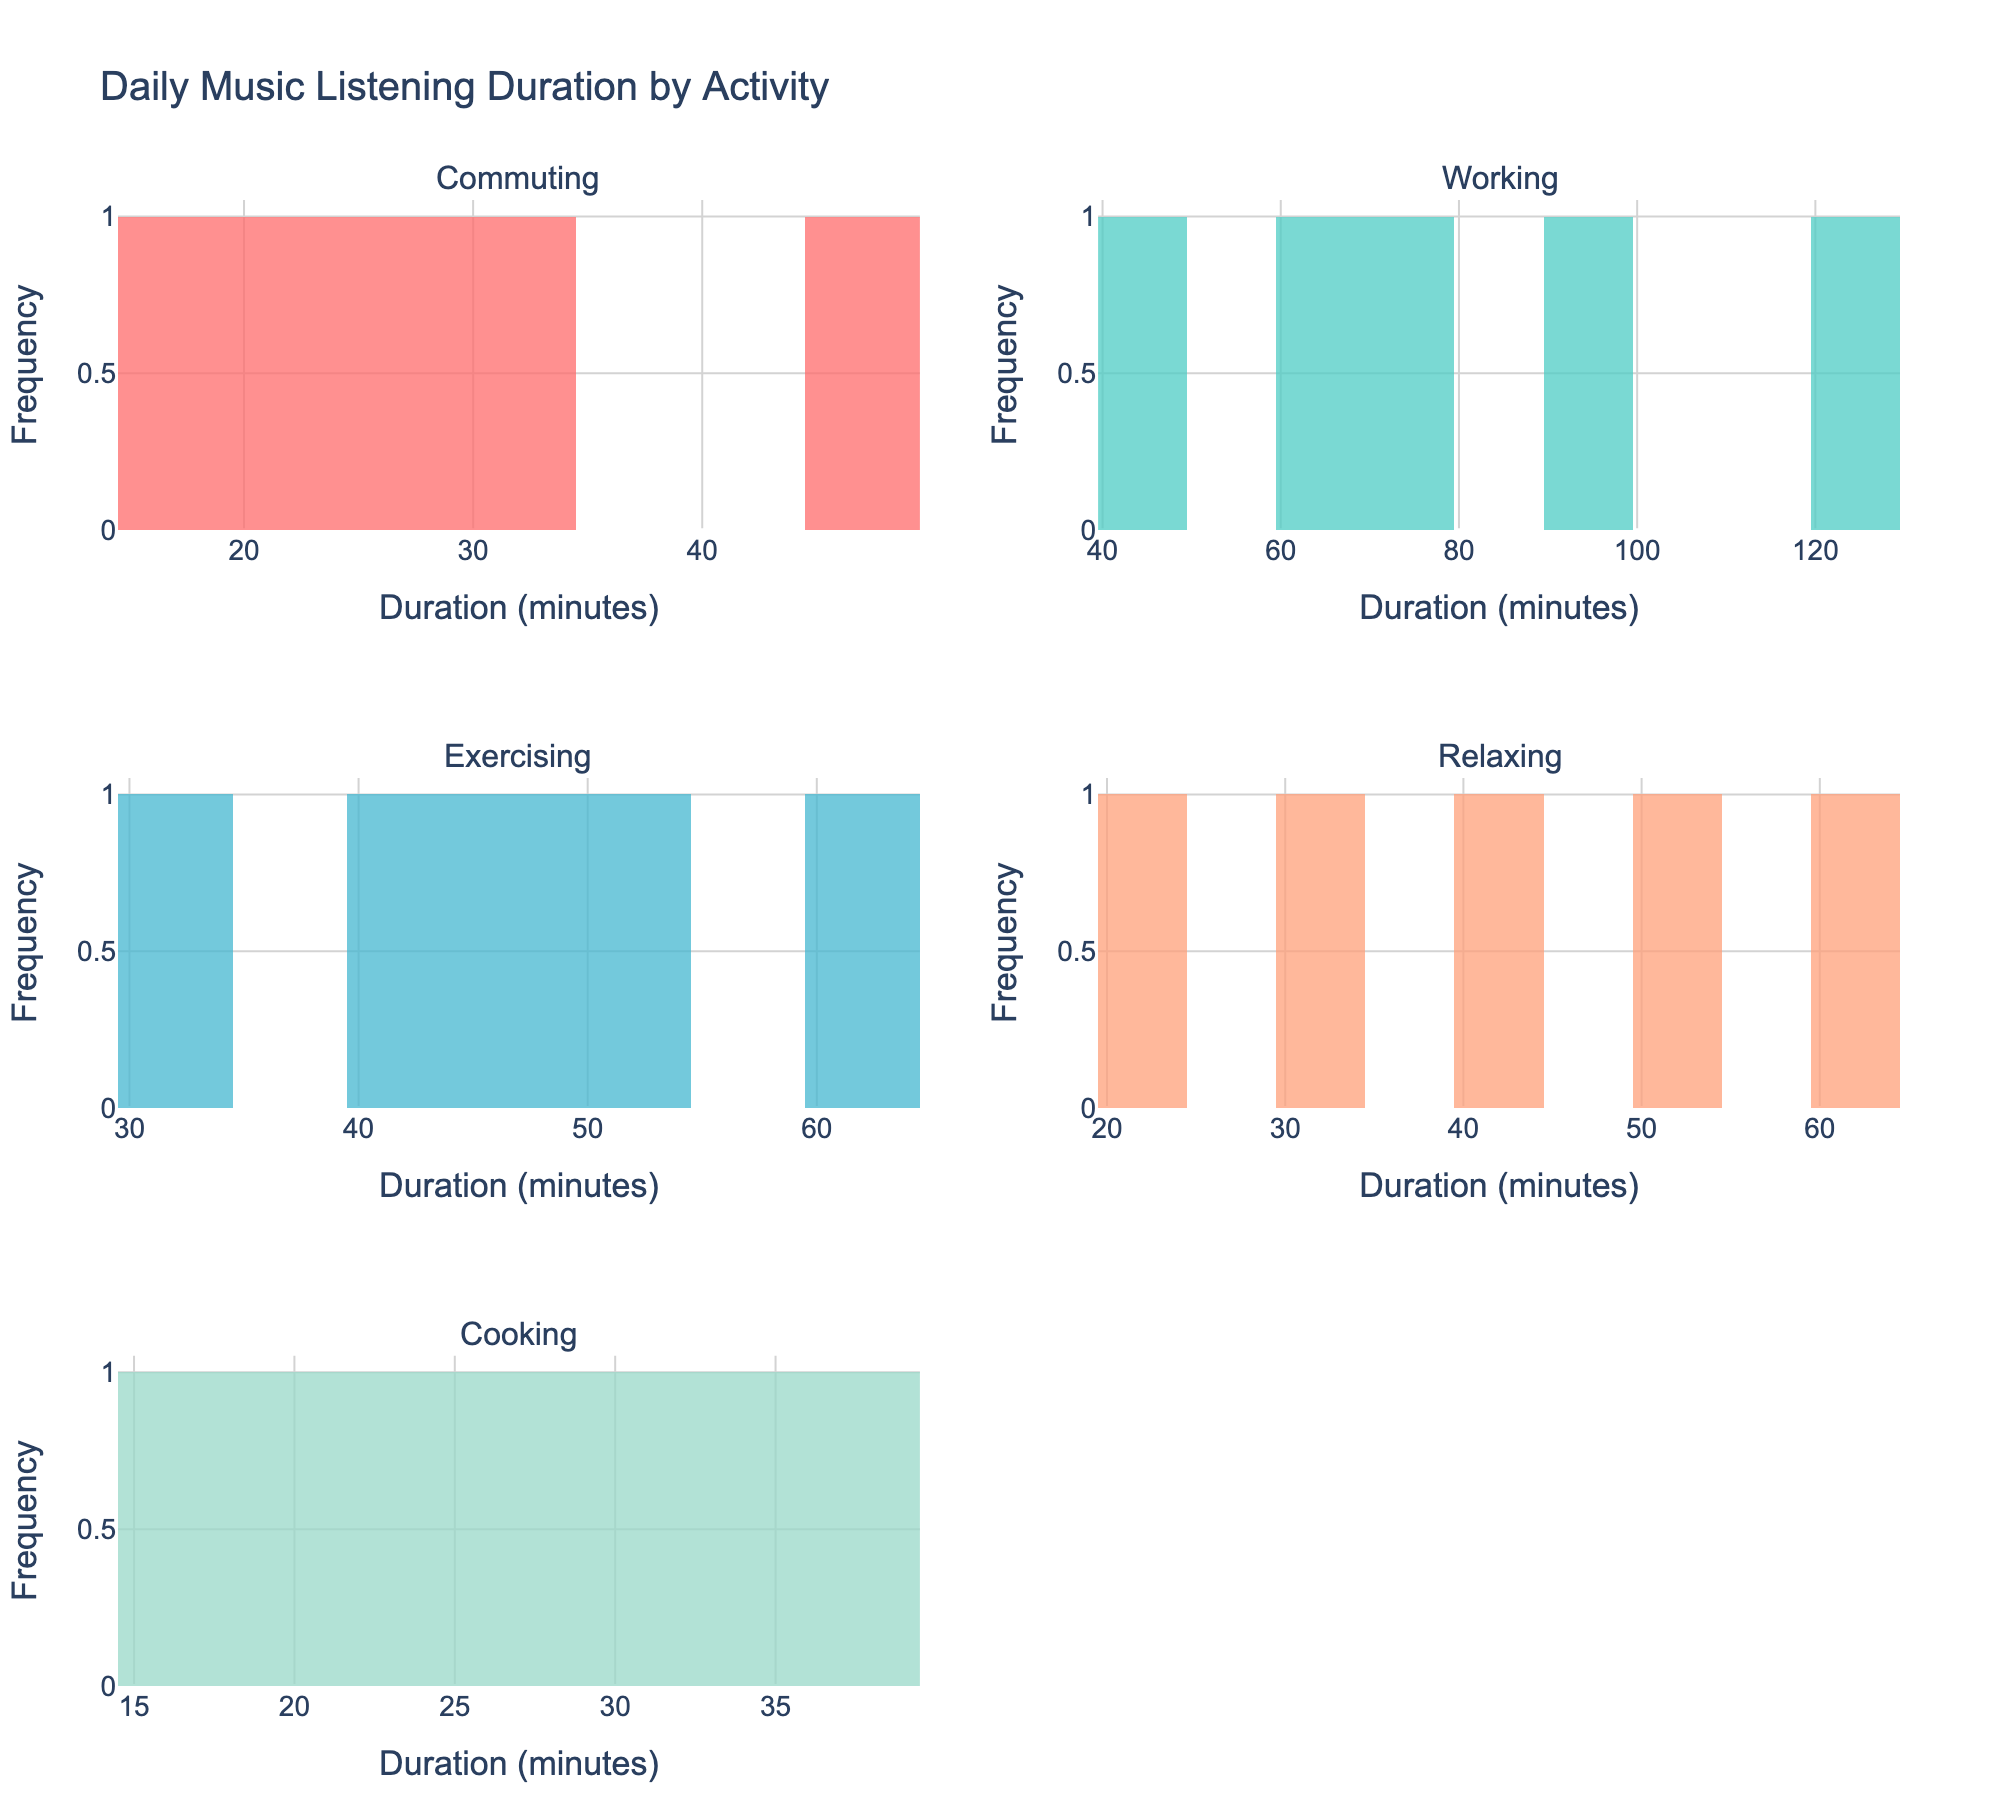What is the title of the figure? The title is usually found at the top of the figure. In this case, it states the overall purpose of the visualizations.
Answer: Daily Music Listening Duration by Activity Which activity has the most varied listening durations? Look at the horizontal spread of bars within each subplot. Longer tails and a wider spread indicate more variance. Working has a more elongated distribution across a larger range (45-120 minutes) compared to other activities.
Answer: Working Which activity has the highest peak in the frequency of listening durations? Find the histogram with the tallest bar. This indicates the most frequent listening duration. Relaxing has the highest peak frequency within its histogram.
Answer: Relaxing What is the general range of listening durations while commuting? Identify the smallest and largest x-values in the histogram for Commuting. The commuting durations range roughly from 15 to 45 minutes.
Answer: 15 to 45 minutes How many activities have a listening duration peak within the 30-40 minute range? Check each subplot to see where the highest bars fall within this range. Commuting, Exercising, and Cooking each have peaks within this range.
Answer: Three activities Which activity shows the least overlap in durations compared to others? Look for the histogram with bars clustered closely together, indicating less distribution overlap. Commuting and Cooking both have relatively tight distributions, but Cooking is slightly tighter.
Answer: Cooking Which histogram shows a higher frequency: Exercising around 60 minutes or Cooking around 20 minutes? Compare the heights of the bars at these specific x-values in the respective histograms. Exercising around 60 minutes has a bar about the same height as Cooking around 20 minutes, but Cooking’s peak is slightly higher.
Answer: Cooking around 20 minutes What is the average listening duration for relaxing? (Consider this more complex as it involves estimation from the histogram.) Estimate the heights and midpoints of bars, multiply them (frequency * midpoint duration), sum these products, and divide by the total frequency. The average is around (20*1 + 30*1 + 40*1 + 50*1 + 60*1)/5 = 40 minutes.
Answer: Approximately 40 minutes 